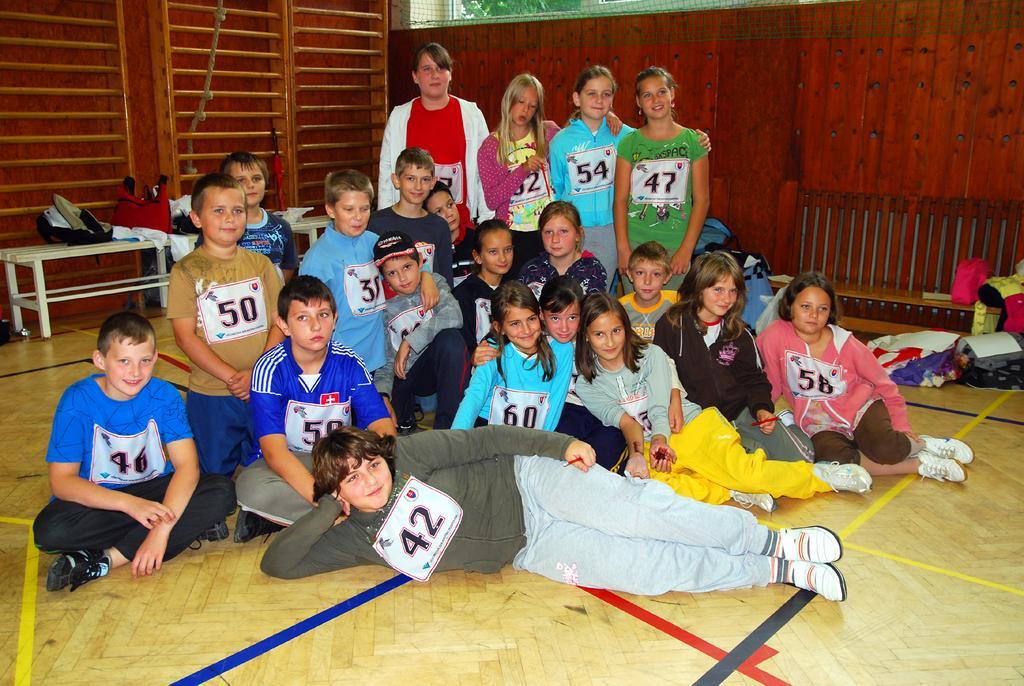How would you summarize this image in a sentence or two? This image consists of many people and there are numbers on their shirts. At the bottom, there is a floor. In the front, the boy is lying on the floor. In the background, there is a wall made up of wood. 